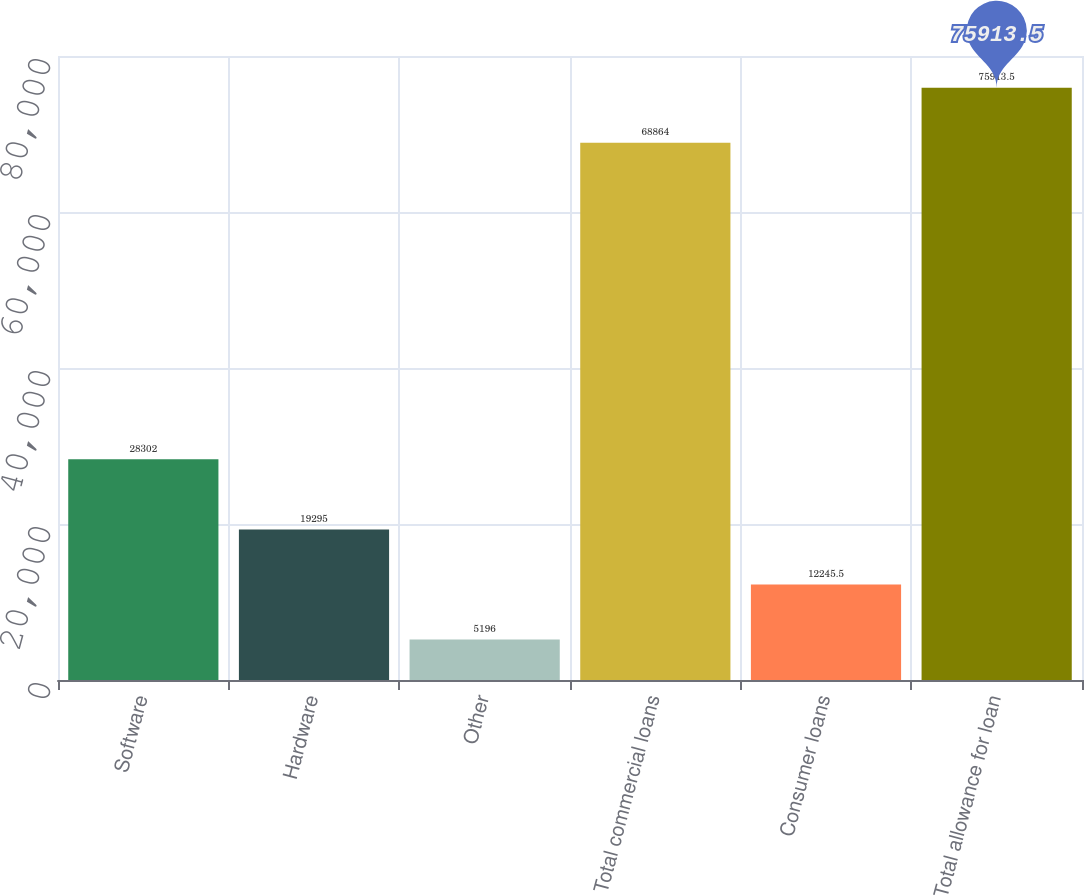<chart> <loc_0><loc_0><loc_500><loc_500><bar_chart><fcel>Software<fcel>Hardware<fcel>Other<fcel>Total commercial loans<fcel>Consumer loans<fcel>Total allowance for loan<nl><fcel>28302<fcel>19295<fcel>5196<fcel>68864<fcel>12245.5<fcel>75913.5<nl></chart> 